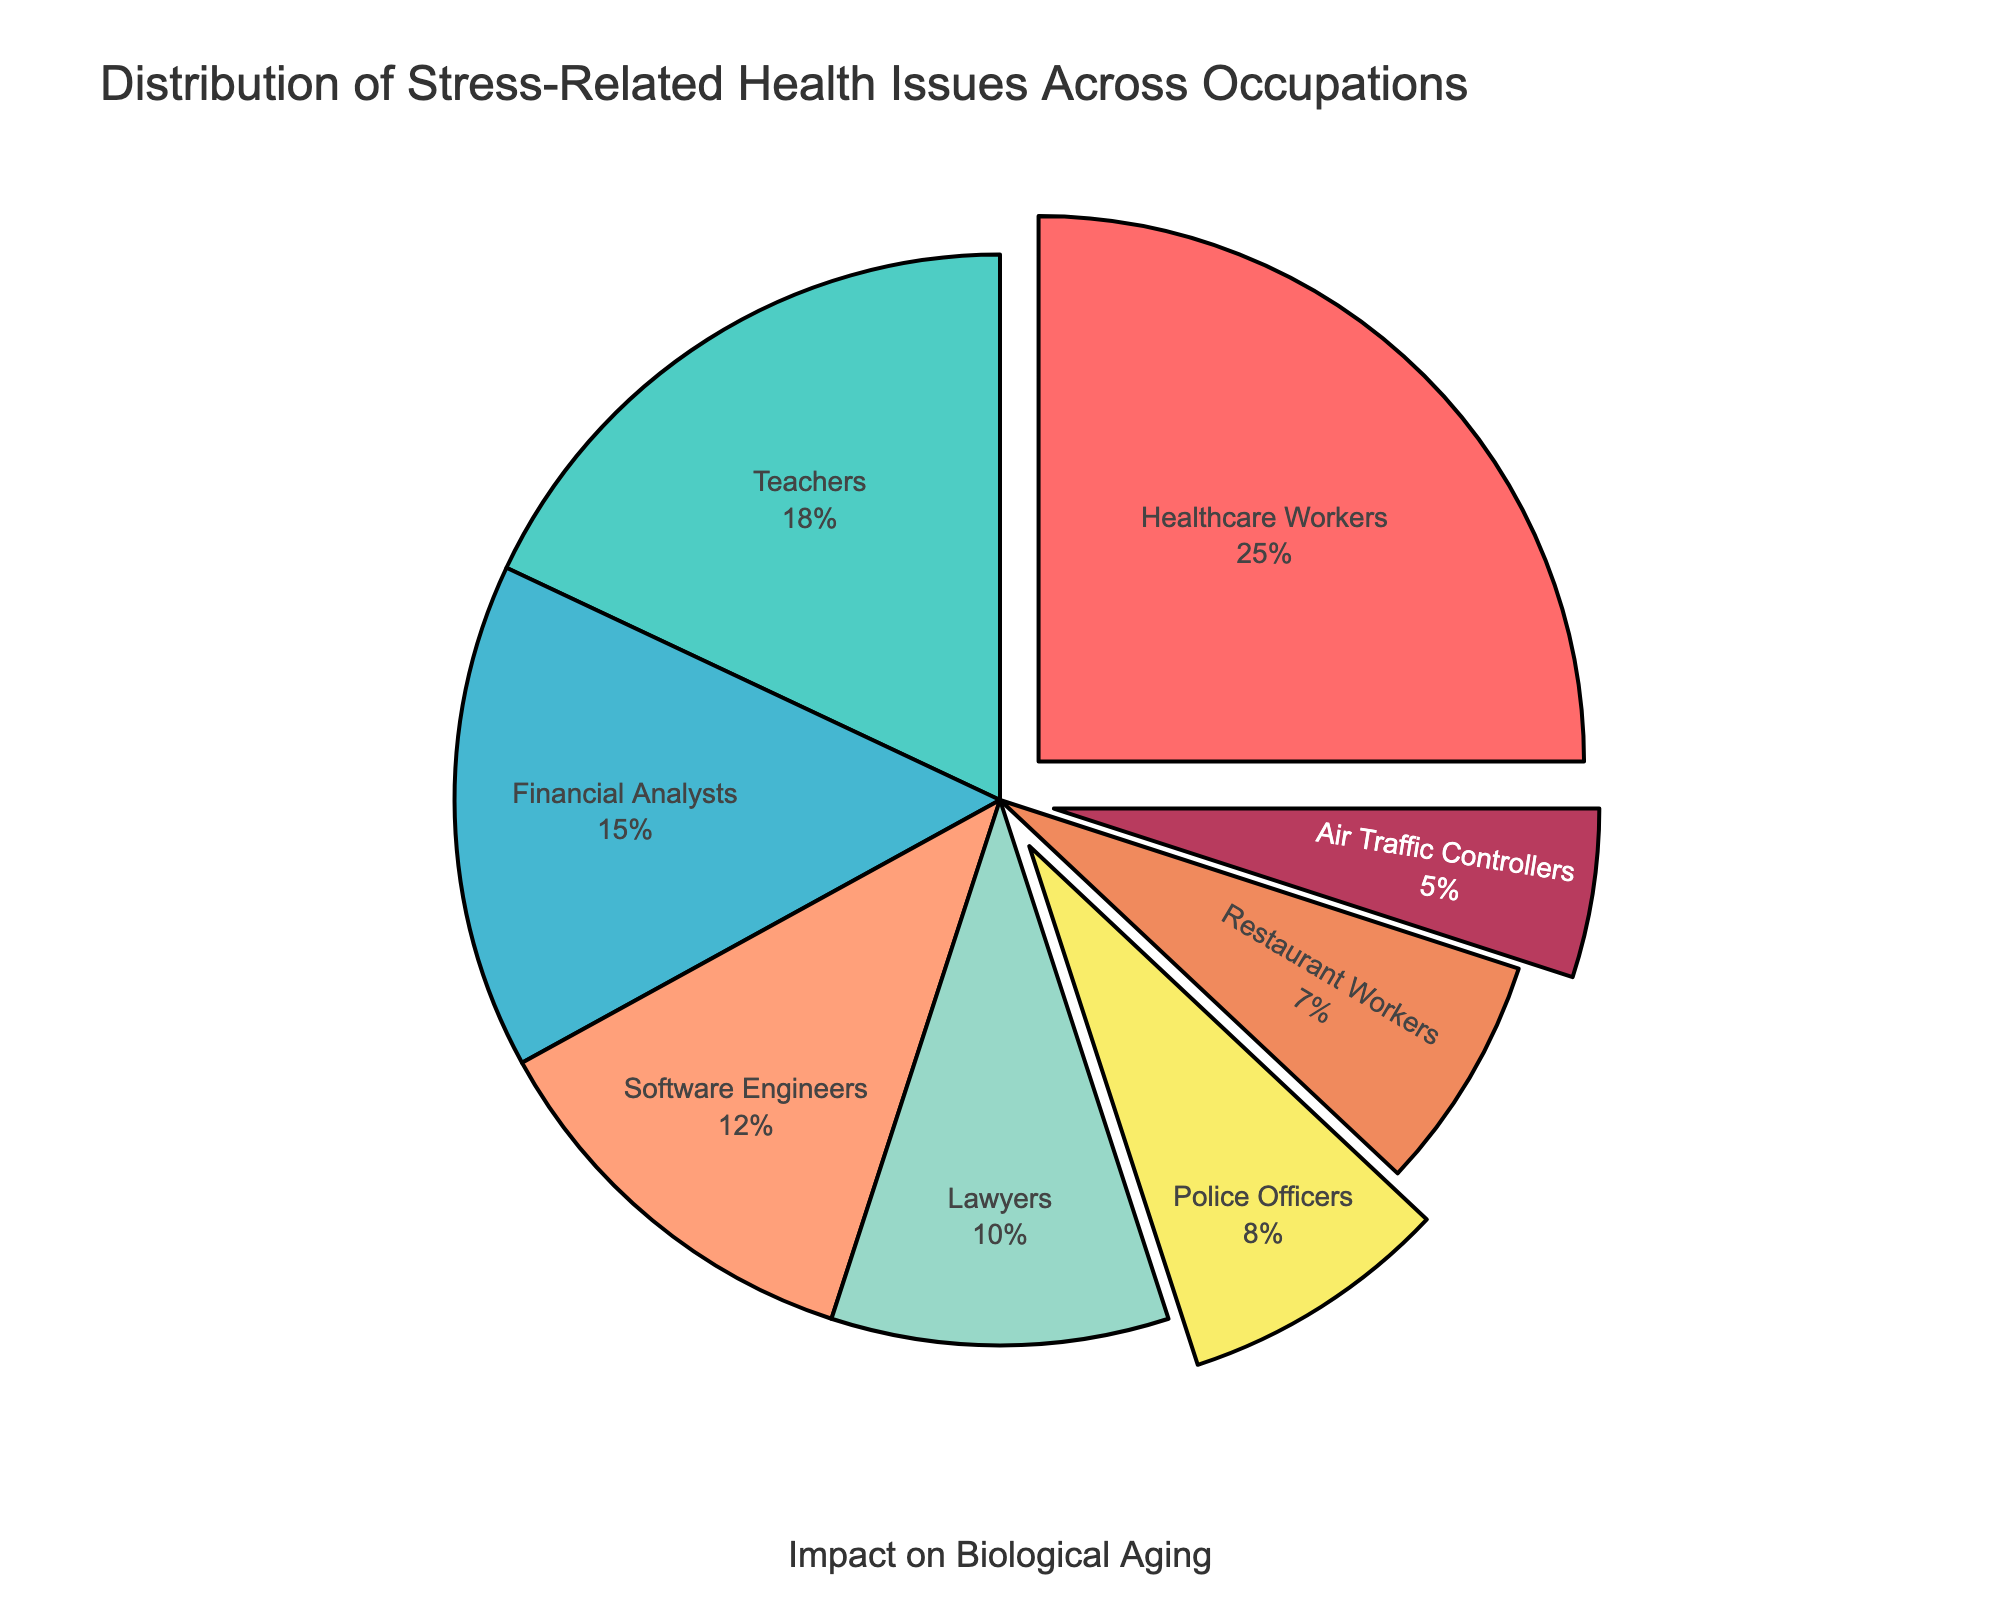What's the percentage of healthcare workers experiencing stress-related health issues? The chart indicates that healthcare workers make up 25% of the distribution of stress-related health issues.
Answer: 25% Which occupation has the highest percentage of stress-related health issues, and what is the primary issue? By looking at the largest section of the pie chart, healthcare workers have the highest percentage at 25%, and their primary stress-related health issue is burnout.
Answer: Healthcare workers, burnout How does the impact on telomere length for financial analysts compare to that of police officers? The hover data shows that financial analysts have an impact on telomere length of -10%, while police officers have -14%. Thus, police officers experience a more significant negative impact on telomere length.
Answer: Police officers, -14% Which occupation is linked to the highest telomere length impact, and what is the health issue? The chart's hover data indicates that police officers experience the highest negative impact on telomere length at -14%, and their primary health issue is PTSD.
Answer: Police officers, PTSD What is the combined percentage of teachers and software engineers experiencing stress-related issues? Teachers have 18%, and software engineers have 12%. Adding these percentages gives a combined total of 18% + 12% = 30%.
Answer: 30% Which group has a higher impact on telomere length, healthcare workers or air traffic controllers? The hover information shows healthcare workers at -12% and air traffic controllers at -13%. Therefore, air traffic controllers have a slightly higher negative impact.
Answer: Air traffic controllers Identify the smallest segment in the pie chart and its corresponding stress-related issue. The smallest segment represents air traffic controllers at 5%, with the primary issue being cardiovascular disease.
Answer: Air traffic controllers, cardiovascular disease What are the primary stress-related health issues for occupations with a telomere impact of -10% or more? Financial analysts (hypertension), restaurant workers (substance abuse), and air traffic controllers (cardiovascular disease) have telomere impacts of -10%, -11%, and -13% respectively.
Answer: Hypertension, Substance Abuse, Cardiovascular Disease Which color represents teachers in the pie chart, and what is their primary stress-related health issue? Teachers are depicted in green and their primary health issue is anxiety disorders.
Answer: Green, anxiety disorders 